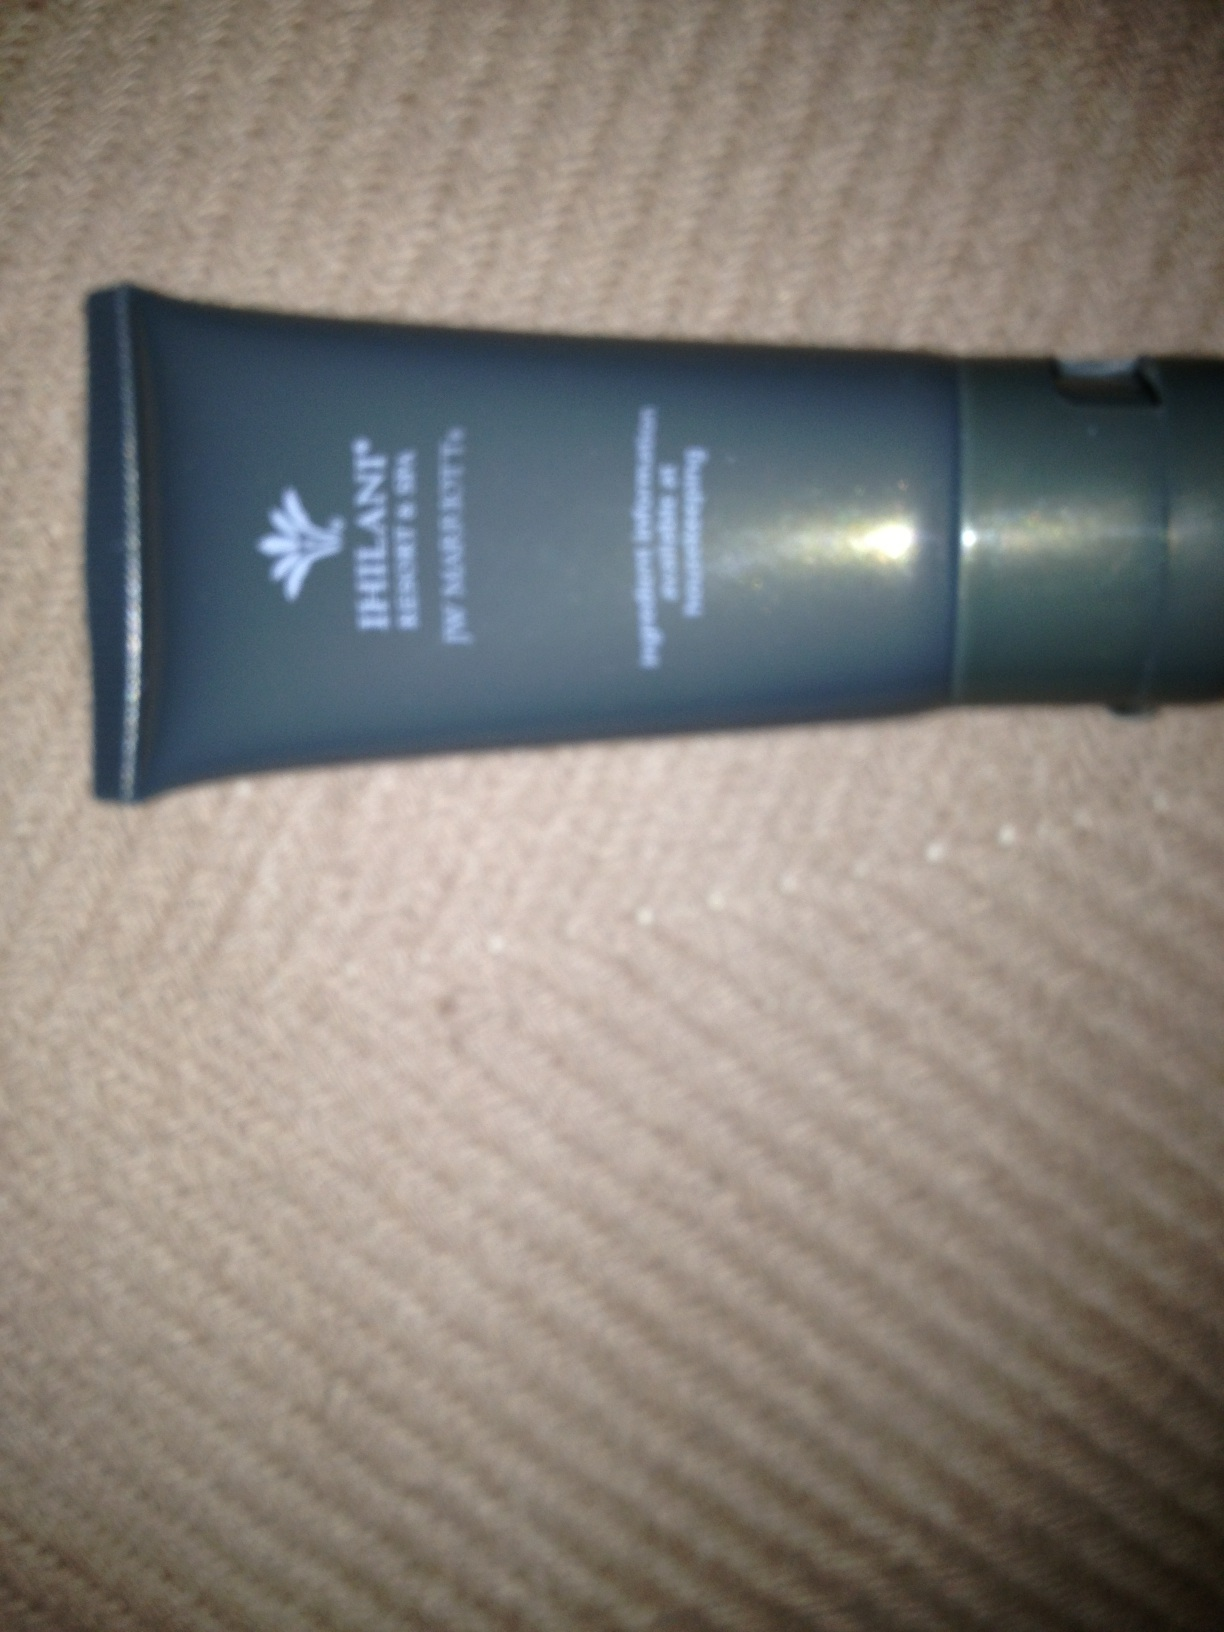What is this? The image shows a tube that appears to be a skincare or cosmetic product. Unfortunately, the specific details such as the brand name or the product type cannot be clearly identified due to the blurry and the close-up nature of the photo. However, we can discern that it is a personal care item. 